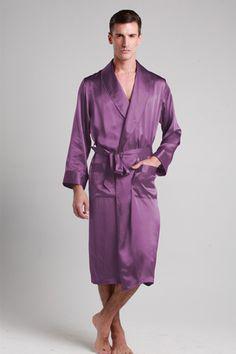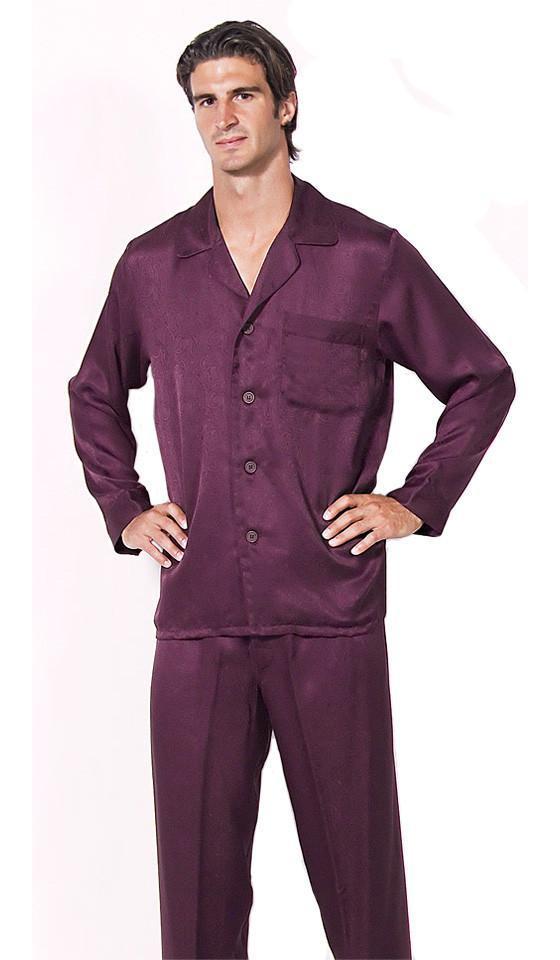The first image is the image on the left, the second image is the image on the right. For the images shown, is this caption "There are no pieces of furniture in the background of these images." true? Answer yes or no. Yes. The first image is the image on the left, the second image is the image on the right. Considering the images on both sides, is "In one image, a man wearing solid color silky pajamas with cuffs on both shirt and pants is standing with one foot forward." valid? Answer yes or no. No. 